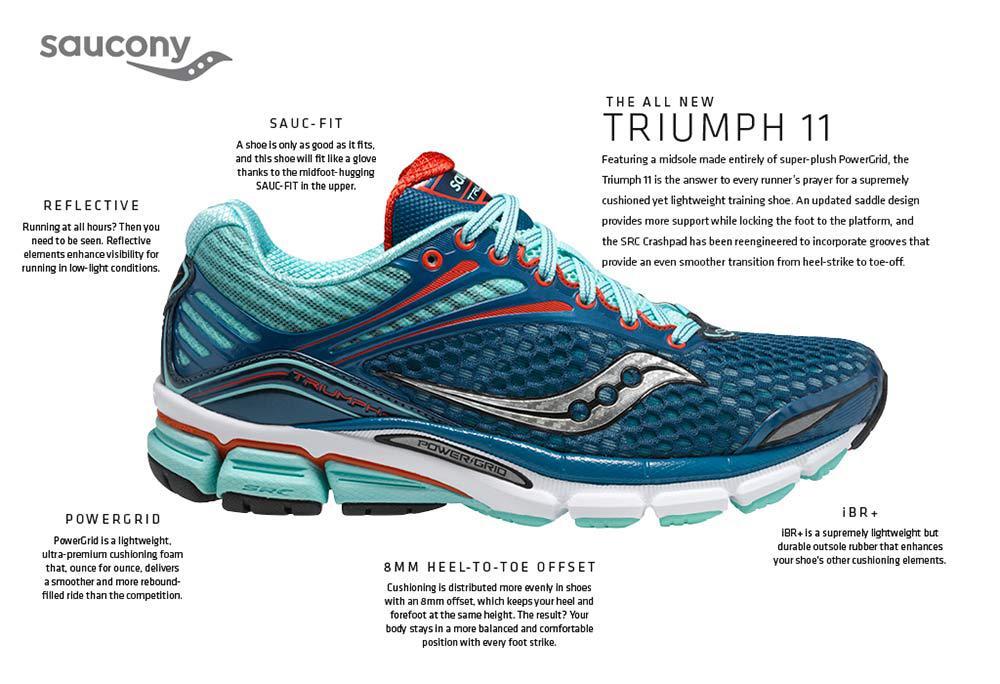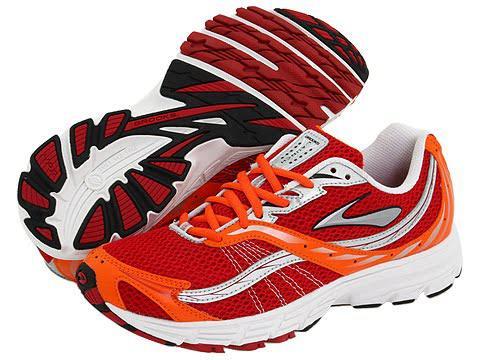The first image is the image on the left, the second image is the image on the right. Given the left and right images, does the statement "Each image shows a single rightward-facing sneaker, and the combined images include lime green and aqua-blue colors, among others." hold true? Answer yes or no. No. The first image is the image on the left, the second image is the image on the right. Given the left and right images, does the statement "The shoes in each of the images have their toes facing the right." hold true? Answer yes or no. No. 